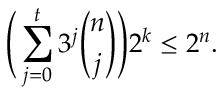<formula> <loc_0><loc_0><loc_500><loc_500>\left ( \sum _ { j = 0 } ^ { t } 3 ^ { j } { \binom { n } { j } } \right ) 2 ^ { k } \leq 2 ^ { n } .</formula> 